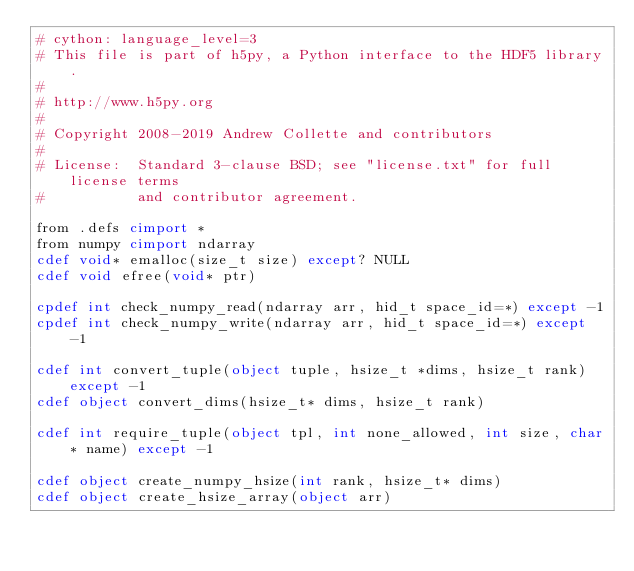<code> <loc_0><loc_0><loc_500><loc_500><_Cython_># cython: language_level=3
# This file is part of h5py, a Python interface to the HDF5 library.
#
# http://www.h5py.org
#
# Copyright 2008-2019 Andrew Collette and contributors
#
# License:  Standard 3-clause BSD; see "license.txt" for full license terms
#           and contributor agreement.

from .defs cimport *
from numpy cimport ndarray
cdef void* emalloc(size_t size) except? NULL
cdef void efree(void* ptr)

cpdef int check_numpy_read(ndarray arr, hid_t space_id=*) except -1
cpdef int check_numpy_write(ndarray arr, hid_t space_id=*) except -1

cdef int convert_tuple(object tuple, hsize_t *dims, hsize_t rank) except -1
cdef object convert_dims(hsize_t* dims, hsize_t rank)

cdef int require_tuple(object tpl, int none_allowed, int size, char* name) except -1

cdef object create_numpy_hsize(int rank, hsize_t* dims)
cdef object create_hsize_array(object arr)
</code> 